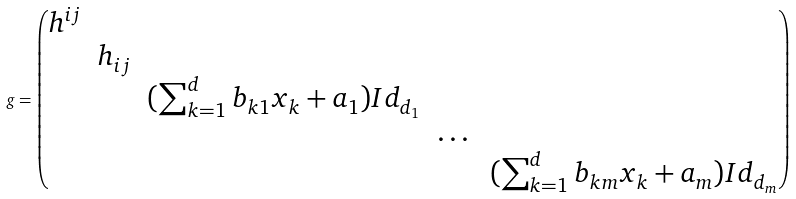Convert formula to latex. <formula><loc_0><loc_0><loc_500><loc_500>g = \begin{pmatrix} h ^ { i j } & & & & \\ & h _ { i j } & & & \\ & & ( \sum _ { k = 1 } ^ { d } b _ { k 1 } x _ { k } + a _ { 1 } ) I d _ { d _ { 1 } } & & \\ & & & \dots & \\ & & & & ( \sum _ { k = 1 } ^ { d } b _ { k m } x _ { k } + a _ { m } ) I d _ { d _ { m } } \\ \end{pmatrix}</formula> 